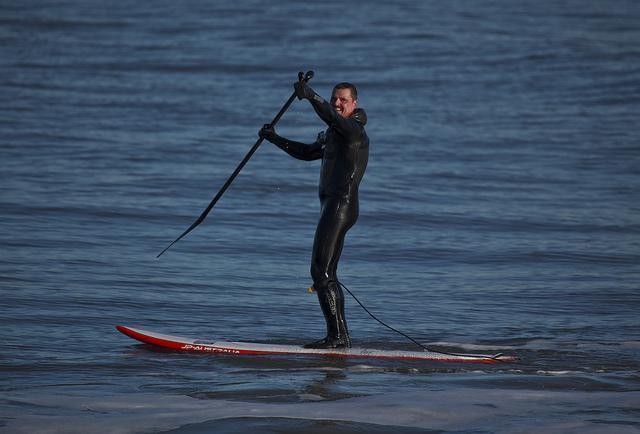How many people are in the photo?
Give a very brief answer. 1. How many vases are on the table?
Give a very brief answer. 0. 